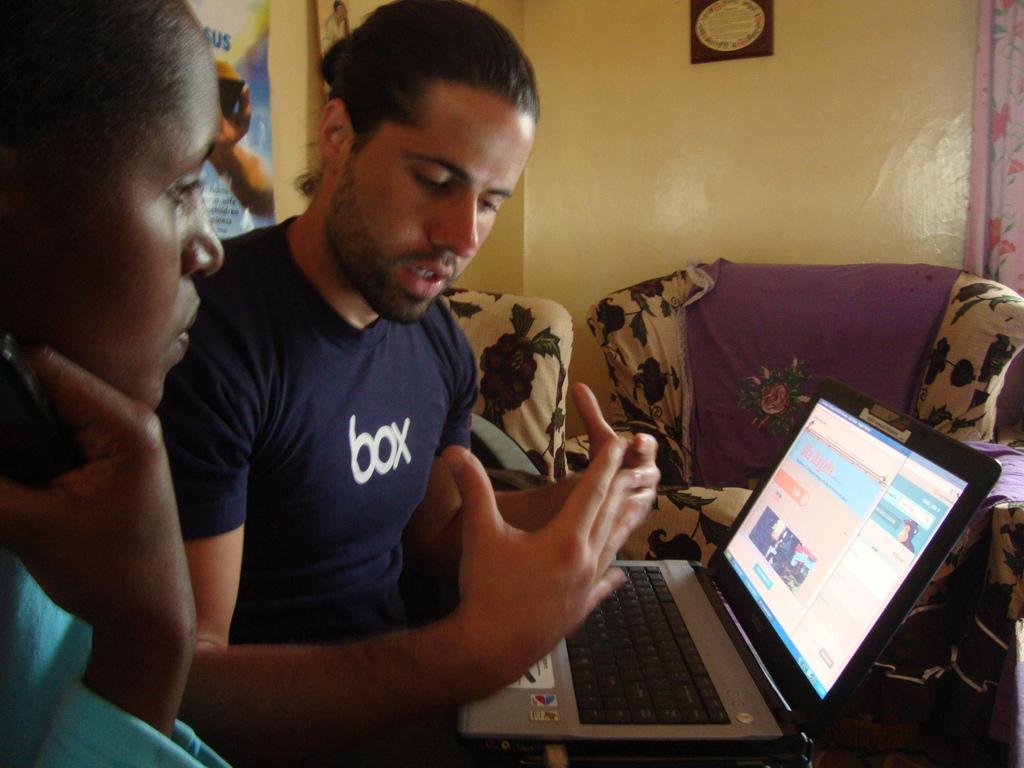Can you describe this image briefly? There is a man in the center of the image and a laptop on his laps, there is a lady on the left side. There are sofas, posters and a curtain in the background area of the image. 